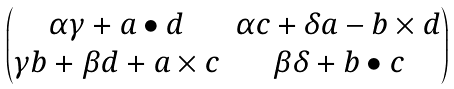Convert formula to latex. <formula><loc_0><loc_0><loc_500><loc_500>\begin{pmatrix} \alpha \gamma + a \bullet d & \alpha c + \delta a - b \times d \\ \gamma b + \beta d + a \times c & \beta \delta + b \bullet c \end{pmatrix}</formula> 